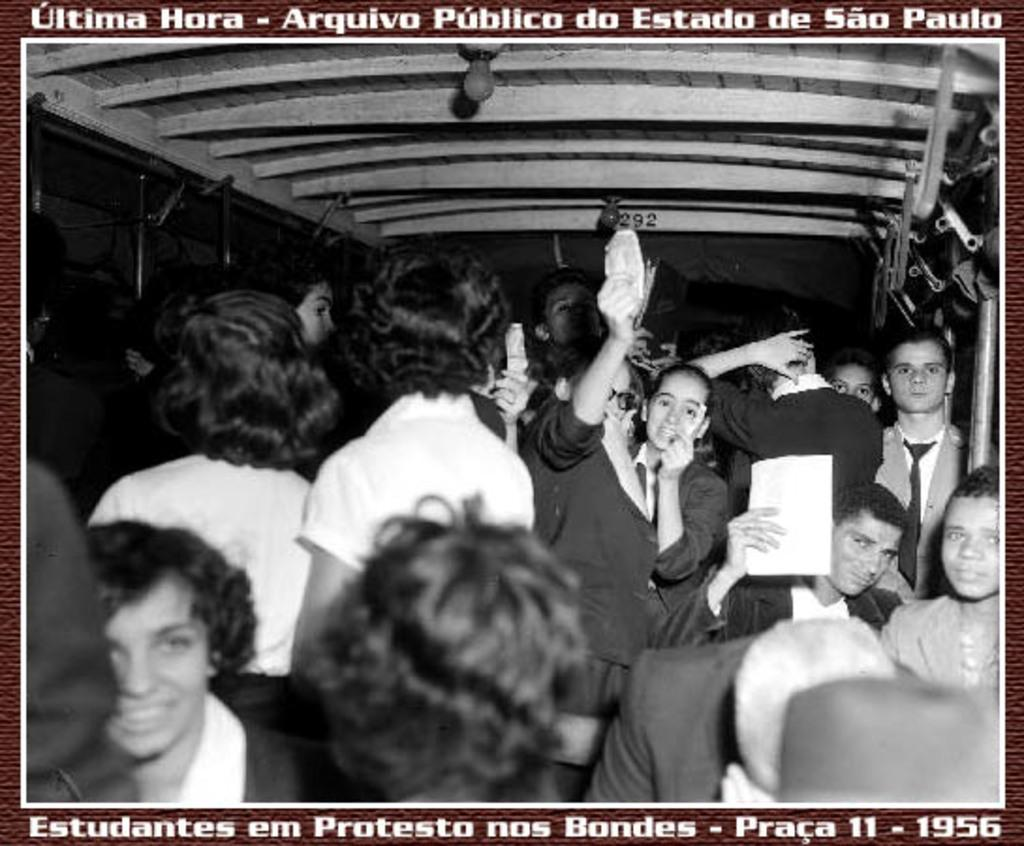What is the main subject of the image? The main subject of the image is a photocopy of a few people. Can you describe any text present in the image? Yes, there is text at the top and bottom of the image. How much wealth does the animal in the image possess? There is no animal present in the image, so it is not possible to determine its wealth. 